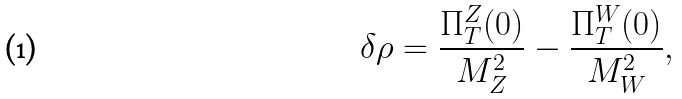Convert formula to latex. <formula><loc_0><loc_0><loc_500><loc_500>\delta \rho = \frac { \Pi _ { T } ^ { Z } ( 0 ) } { M _ { Z } ^ { 2 } } - \frac { \Pi _ { T } ^ { W } ( 0 ) } { M _ { W } ^ { 2 } } ,</formula> 